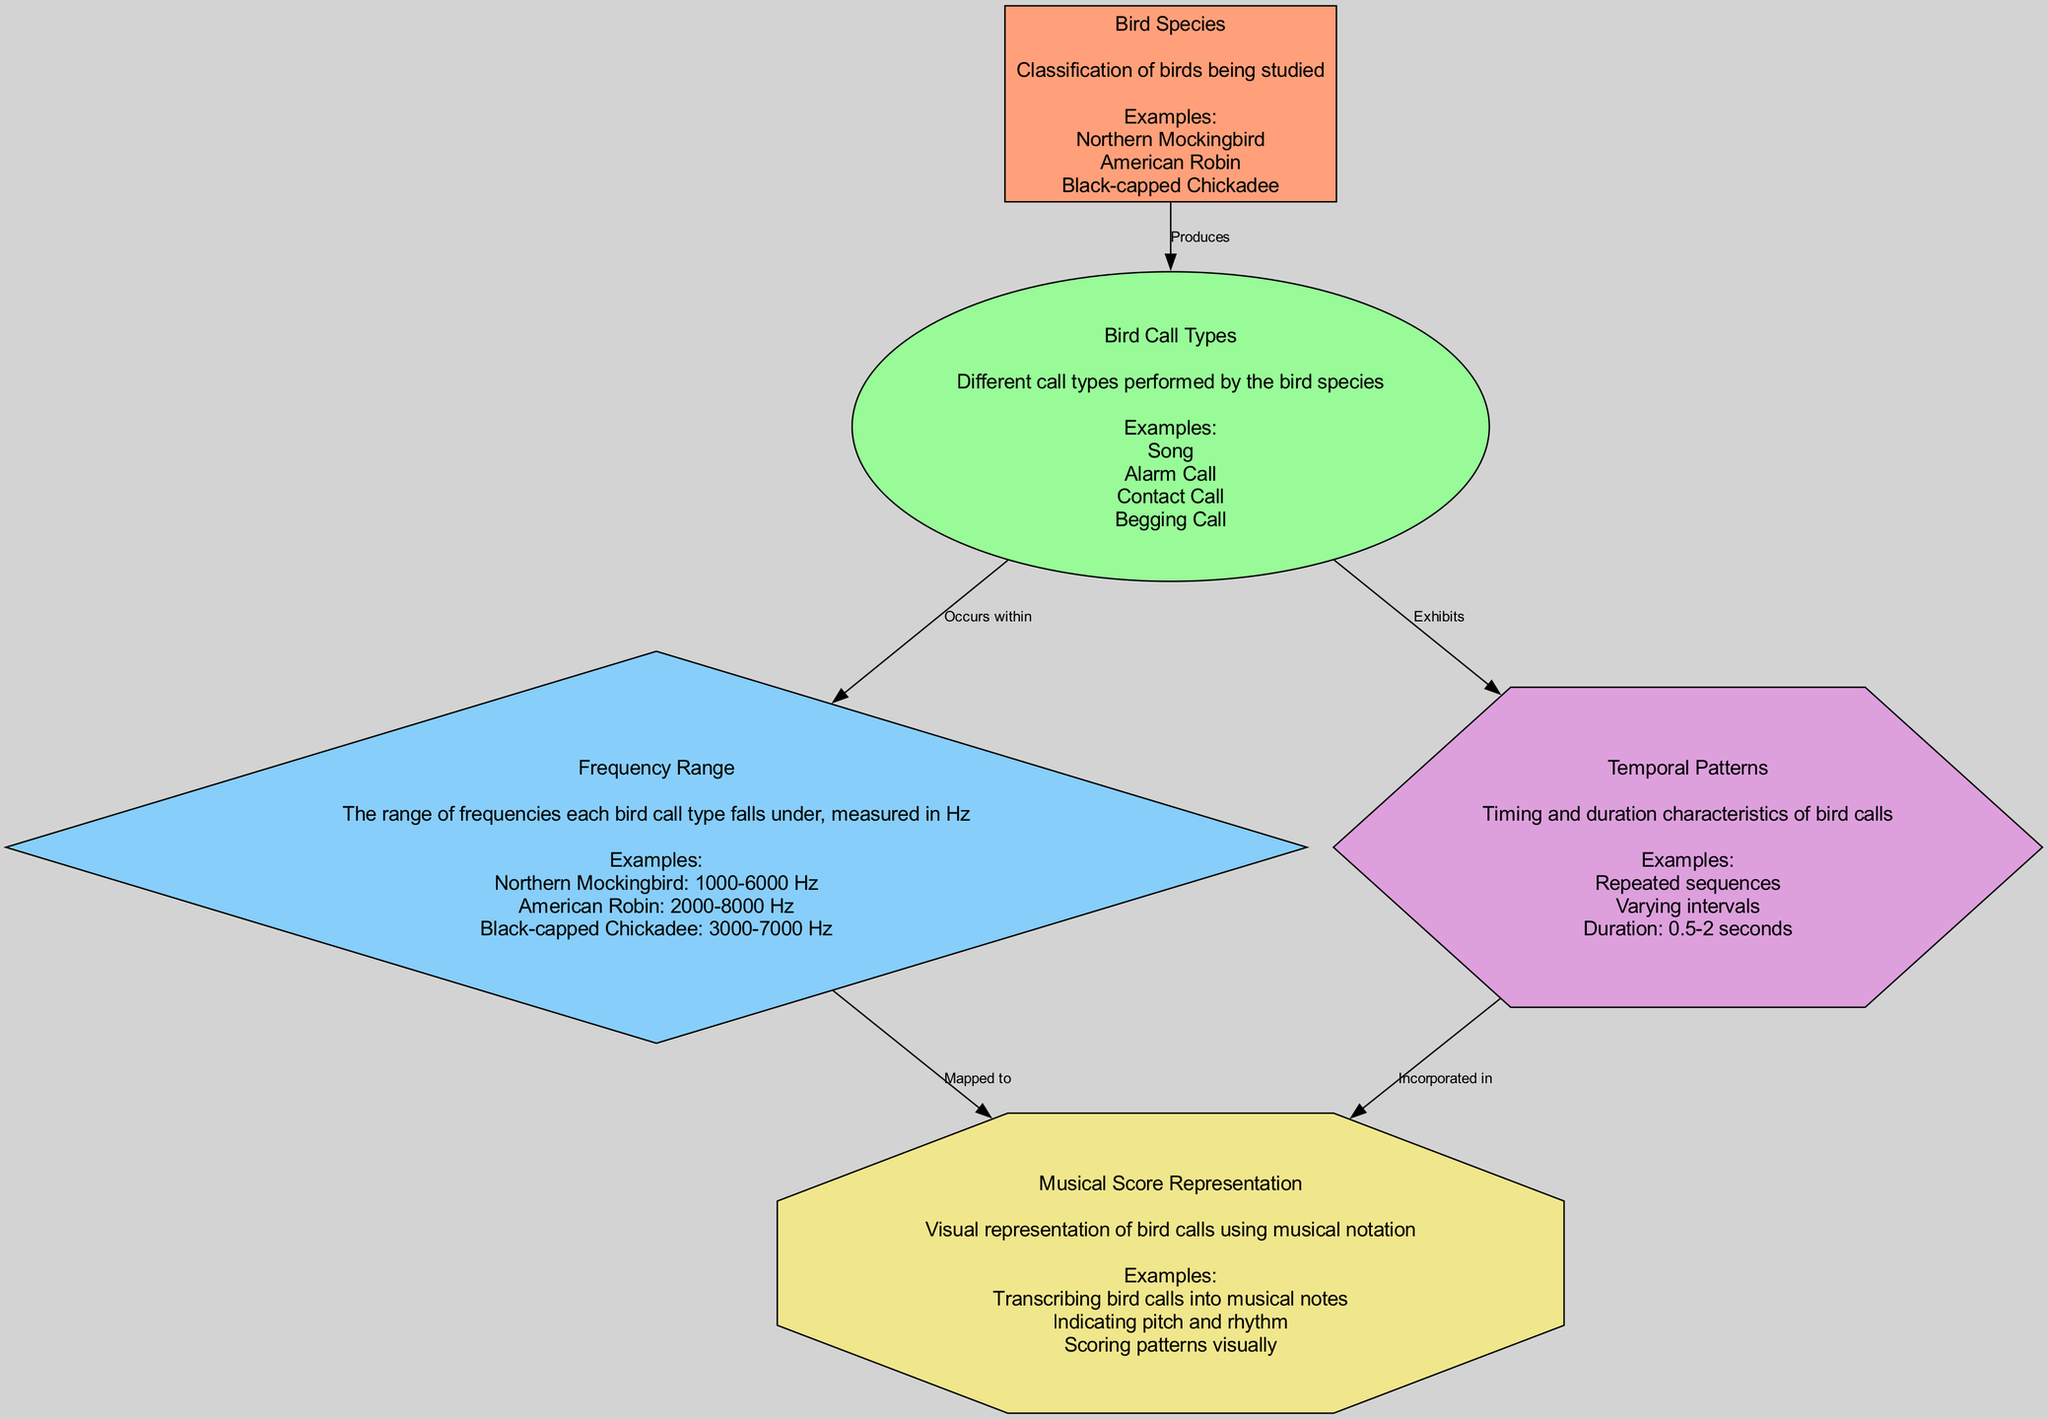What types of bird calls are represented in the diagram? The diagram lists four types of bird calls: Song, Alarm Call, Contact Call, and Begging Call. These are shown in the node labeled "Bird Call Types."
Answer: Song, Alarm Call, Contact Call, Begging Call Which bird species has a frequency range of 2000 to 8000 Hz? The data specifies that the American Robin falls within the frequency range of 2000-8000 Hz, which is indicated in the node labeled "Frequency Range."
Answer: American Robin How many nodes are present in the diagram? By counting the nodes provided in the data, there are five distinct nodes: Bird Species, Bird Call Types, Frequency Range, Temporal Patterns, and Musical Score Representation.
Answer: Five What relationship exists between "Frequency Range" and "Musical Score Representation"? The data shows that the "Frequency Range" is mapped to the "Musical Score Representation." This indicates how the frequency data is visually transcribed into musical notation.
Answer: Mapped to Which bird call type exhibits varying intervals according to the diagram? The diagram states that the "Temporal Patterns" exhibit varying intervals. This indicates that the timing characteristics of the calls vary among repeated sequences.
Answer: Varying intervals Which bird species produces a song? The node labeled "Bird Species" lists the Northern Mockingbird among others that are known to produce a song. This association is illustrated through the "Produces" relationship.
Answer: Northern Mockingbird What color is used to represent the "Bird Call Types" node in the diagram? The "Bird Call Types" node is filled with a green shade (#98FB98), as per the specified node styles for the diagram.
Answer: Green What is the duration range of bird calls as noted in the diagram? The "Temporal Patterns" section indicates that the duration ranges from 0.5 to 2 seconds, specifying the characteristics of the bird calls.
Answer: 0.5-2 seconds 